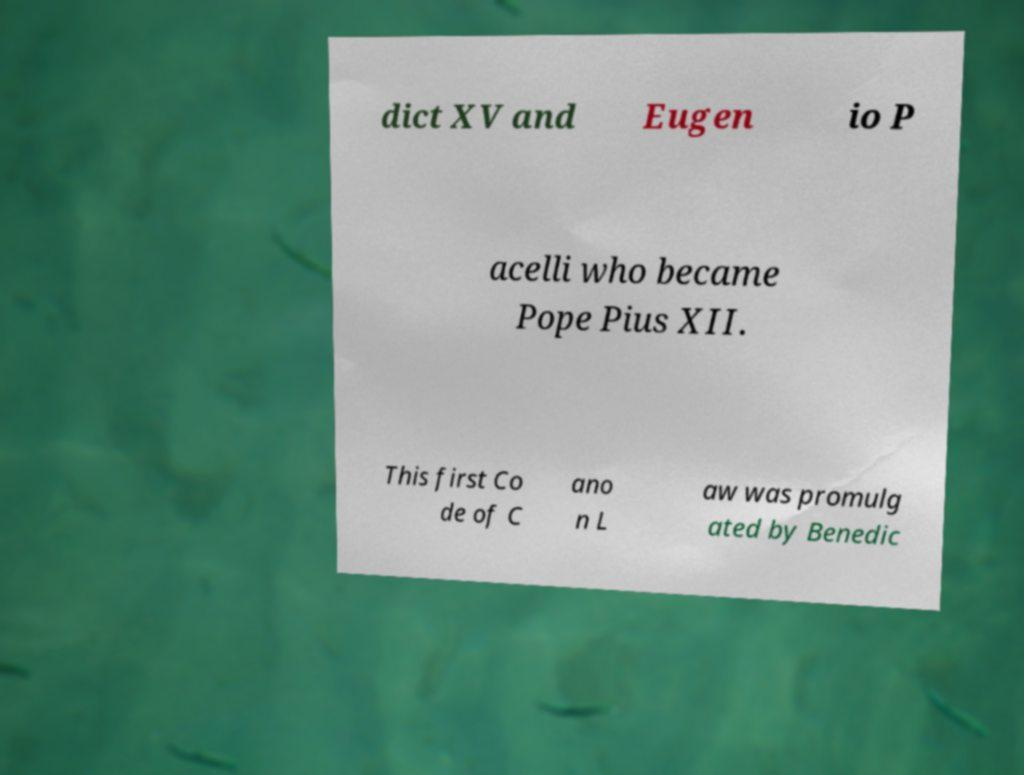What messages or text are displayed in this image? I need them in a readable, typed format. dict XV and Eugen io P acelli who became Pope Pius XII. This first Co de of C ano n L aw was promulg ated by Benedic 